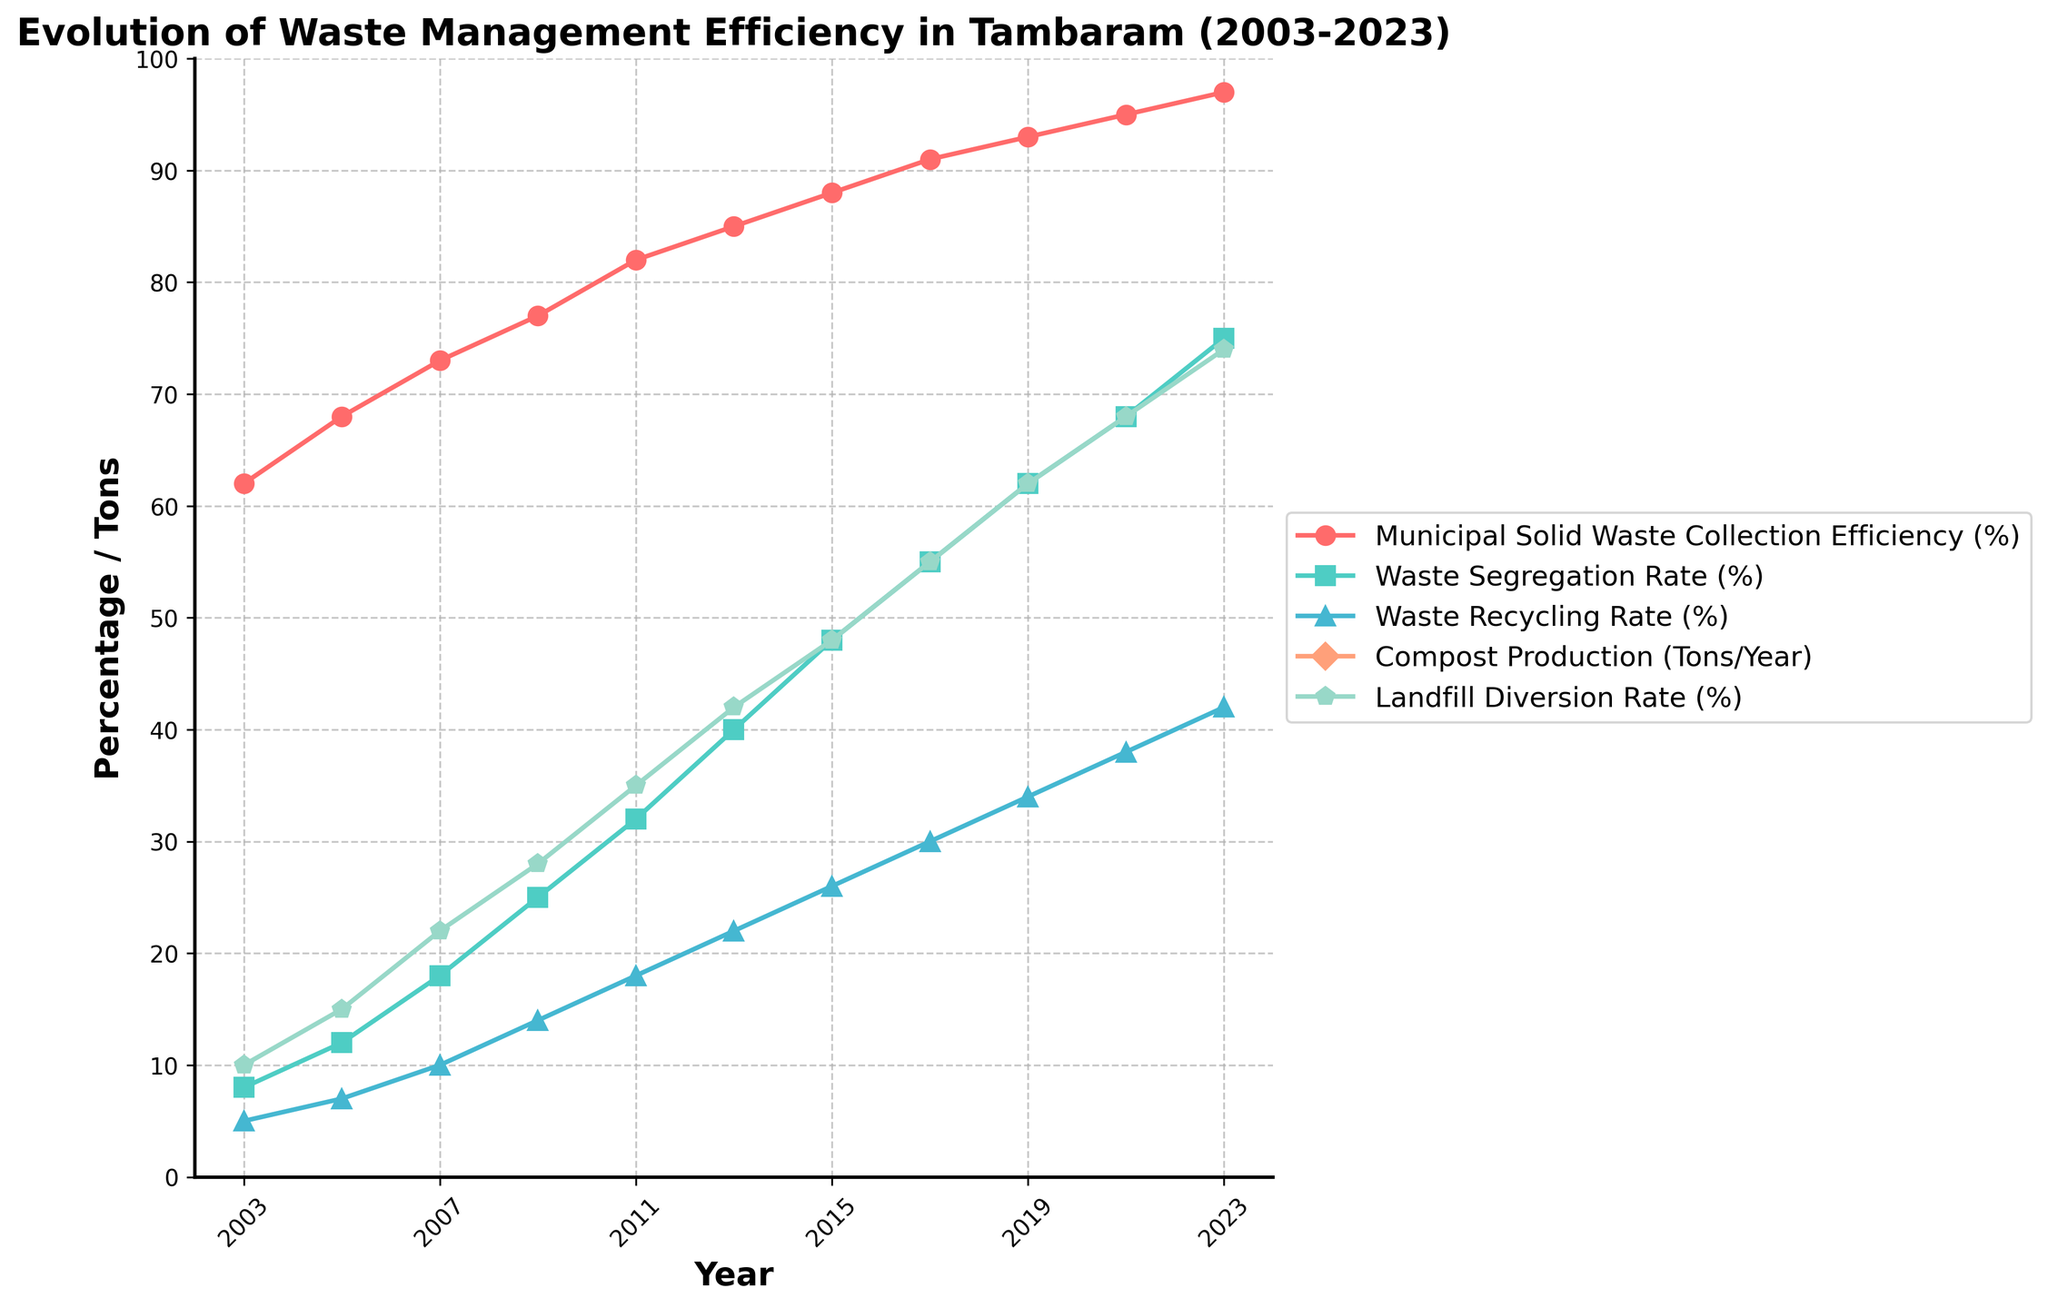What is the municipal solid waste collection efficiency rate in 2023? To find the municipal solid waste collection efficiency rate in 2023, look at the year 2023 on the x-axis and then find the corresponding data point for the municipal solid waste collection efficiency rate.
Answer: 97% Which year had the lowest waste segregation rate and what was the rate? The lowest value in the waste segregation rate series is 8%. Find the year corresponding to this value.
Answer: 2003 What is the difference in waste recycling rates between 2013 and 2023? To find the difference, look at the waste recycling rates for 2013 and 2023, which are 22% and 42%, respectively. Subtract the rate for 2013 from that of 2023.
Answer: 20% In which year did compost production reach 5600 tons/year, and what was the landfill diversion rate in the same year? The year when compost production is 5600 tons/year is 2015. Look at the landfill diversion rate for the same year.
Answer: 48% Which metric showed the most significant improvement between 2003 and 2023? To determine which metric showed the most significant improvement, calculate the difference between the values for 2003 and 2023 for each metric. The metric with the highest increase is the one that improved the most.
Answer: Waste Segregation Rate How did the landfill diversion rate change between 2005 and 2015? The landfill diversion rate in 2005 and 2015 are 15% and 48%, respectively. Subtract the rate in 2005 from that in 2015.
Answer: Increased by 33% What is the average municipal solid waste collection efficiency rate over the entire period? Sum all the values of the municipal solid waste collection efficiency rate and divide by the number of years (11).
Answer: 82.1% Between 2011 and 2019, which metric increased the least and by how much? Calculate the increase for each metric between 2011 and 2019. The metric with the smallest difference had the least increase.
Answer: Waste Recycling Rate, 16% What was the relationship between waste segregation rate and landfill diversion rate in 2023? Look at the values for waste segregation rate and landfill diversion rate in 2023. Compare both rates to describe their relationship.
Answer: Both were 75% and 74%, respectively, which are relatively close In what year did the compost production exceed 8000 tons/year, and what was the municipal solid waste collection efficiency rate in that year? The compost production exceeded 8000 tons/year in 2021. Look for the municipal solid waste collection efficiency rate in the same year.
Answer: 2021, 95% 